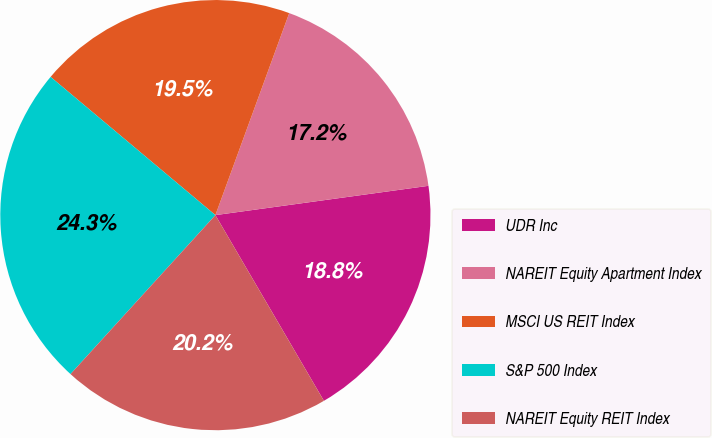Convert chart to OTSL. <chart><loc_0><loc_0><loc_500><loc_500><pie_chart><fcel>UDR Inc<fcel>NAREIT Equity Apartment Index<fcel>MSCI US REIT Index<fcel>S&P 500 Index<fcel>NAREIT Equity REIT Index<nl><fcel>18.76%<fcel>17.25%<fcel>19.47%<fcel>24.35%<fcel>20.18%<nl></chart> 